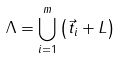Convert formula to latex. <formula><loc_0><loc_0><loc_500><loc_500>\Lambda = \bigcup _ { i = 1 } ^ { m } \left ( \vec { t } _ { i } + L \right )</formula> 